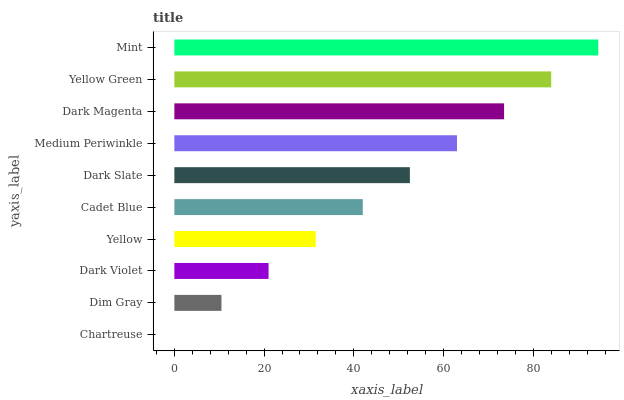Is Chartreuse the minimum?
Answer yes or no. Yes. Is Mint the maximum?
Answer yes or no. Yes. Is Dim Gray the minimum?
Answer yes or no. No. Is Dim Gray the maximum?
Answer yes or no. No. Is Dim Gray greater than Chartreuse?
Answer yes or no. Yes. Is Chartreuse less than Dim Gray?
Answer yes or no. Yes. Is Chartreuse greater than Dim Gray?
Answer yes or no. No. Is Dim Gray less than Chartreuse?
Answer yes or no. No. Is Dark Slate the high median?
Answer yes or no. Yes. Is Cadet Blue the low median?
Answer yes or no. Yes. Is Mint the high median?
Answer yes or no. No. Is Dark Slate the low median?
Answer yes or no. No. 